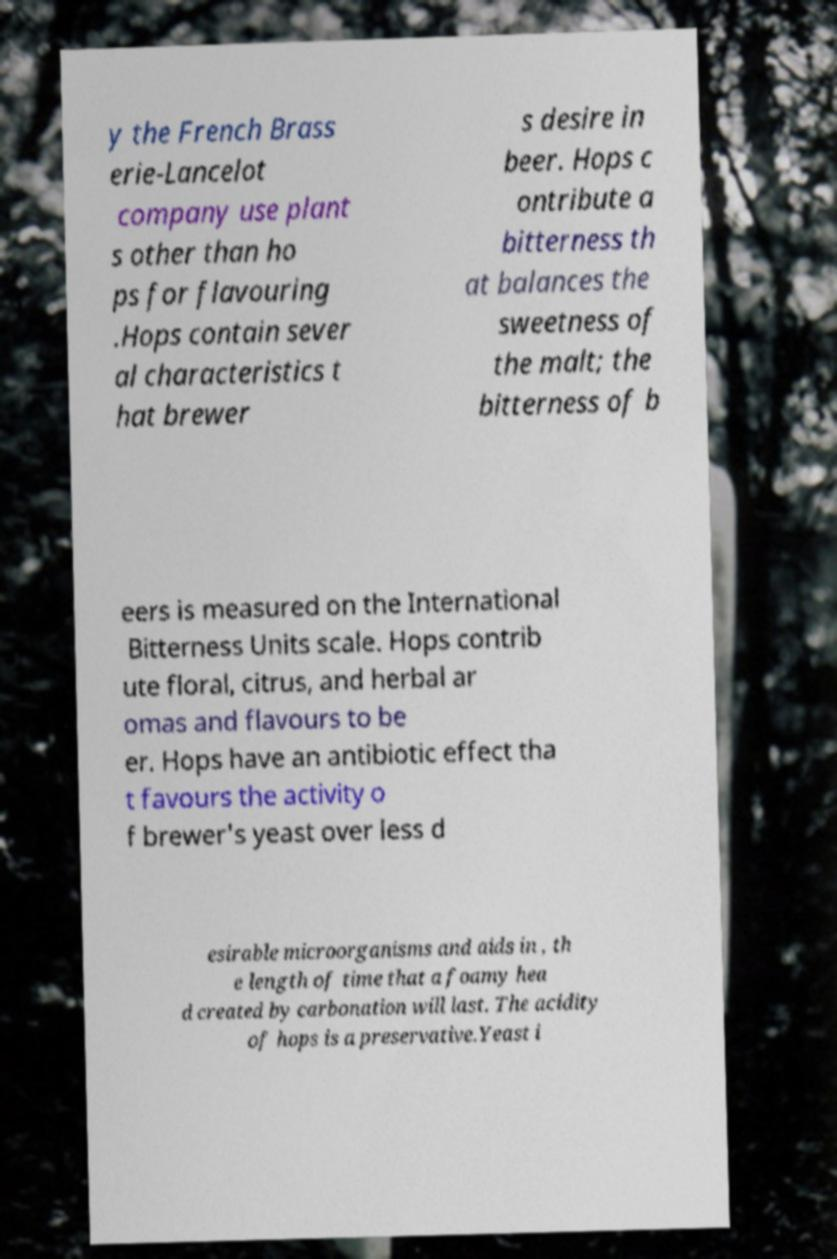Can you accurately transcribe the text from the provided image for me? y the French Brass erie-Lancelot company use plant s other than ho ps for flavouring .Hops contain sever al characteristics t hat brewer s desire in beer. Hops c ontribute a bitterness th at balances the sweetness of the malt; the bitterness of b eers is measured on the International Bitterness Units scale. Hops contrib ute floral, citrus, and herbal ar omas and flavours to be er. Hops have an antibiotic effect tha t favours the activity o f brewer's yeast over less d esirable microorganisms and aids in , th e length of time that a foamy hea d created by carbonation will last. The acidity of hops is a preservative.Yeast i 